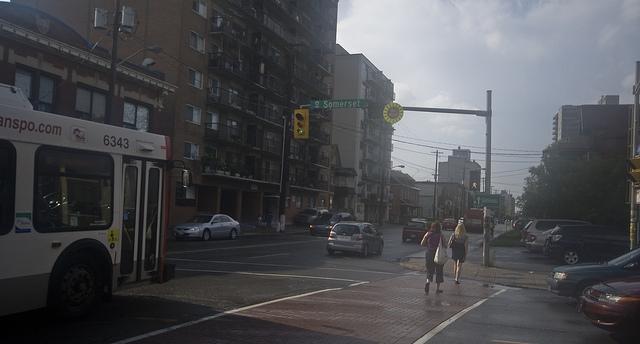How many people can be seen?
Give a very brief answer. 2. How many green lights are there?
Give a very brief answer. 1. How many cars are there?
Give a very brief answer. 3. How many beds can be seen?
Give a very brief answer. 0. 